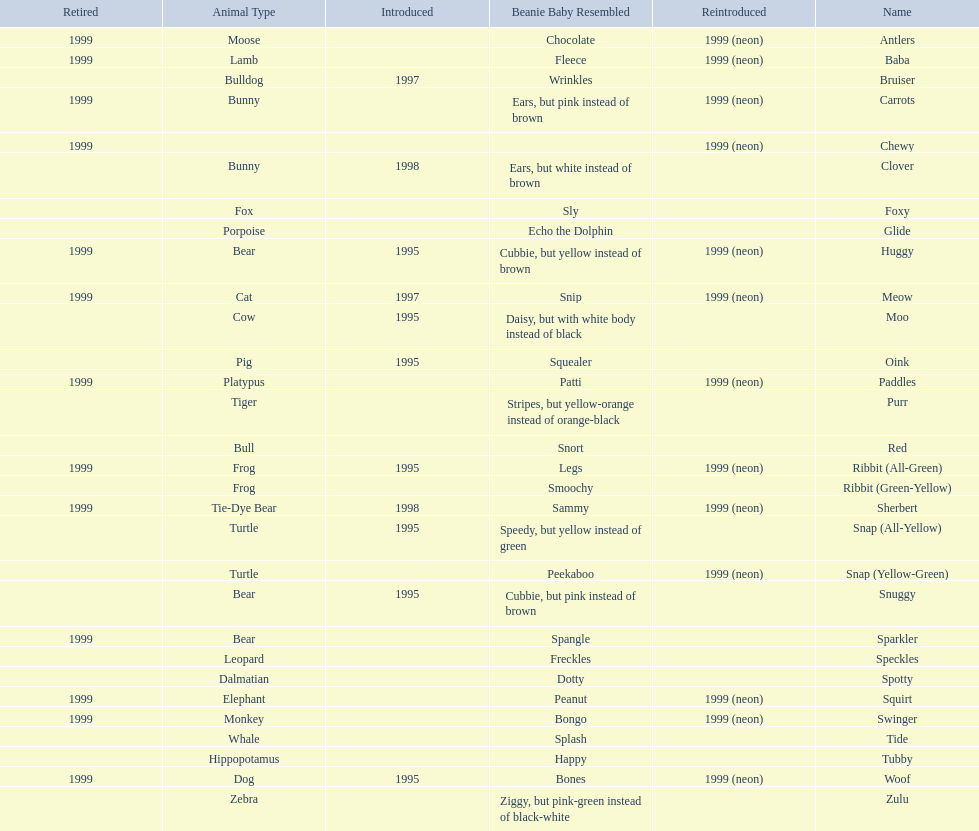What is the number of frog pillow pals? 2. 